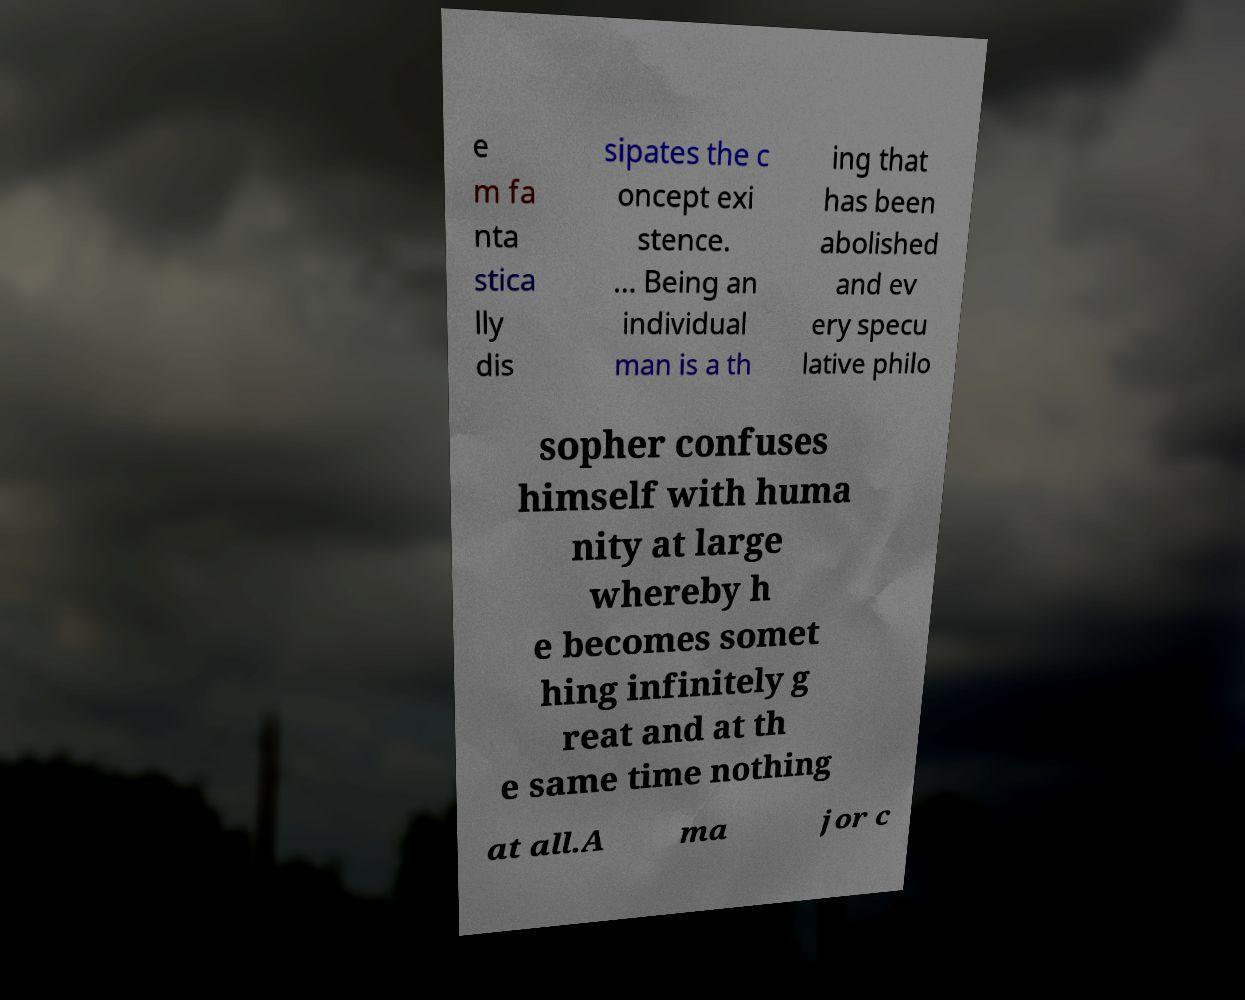Could you assist in decoding the text presented in this image and type it out clearly? e m fa nta stica lly dis sipates the c oncept exi stence. ... Being an individual man is a th ing that has been abolished and ev ery specu lative philo sopher confuses himself with huma nity at large whereby h e becomes somet hing infinitely g reat and at th e same time nothing at all.A ma jor c 